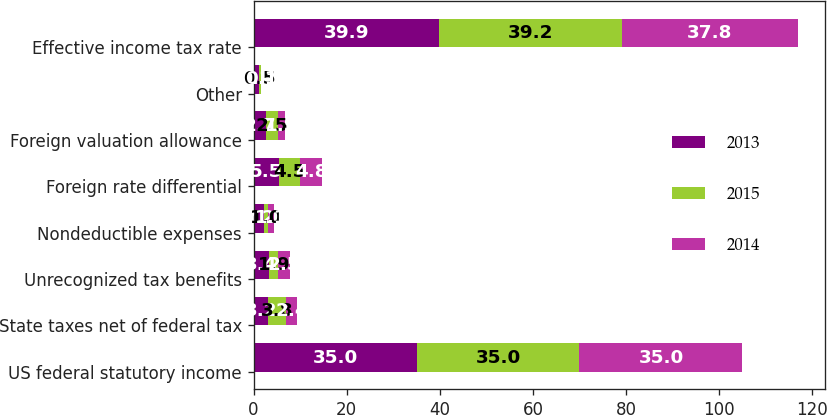Convert chart. <chart><loc_0><loc_0><loc_500><loc_500><stacked_bar_chart><ecel><fcel>US federal statutory income<fcel>State taxes net of federal tax<fcel>Unrecognized tax benefits<fcel>Nondeductible expenses<fcel>Foreign rate differential<fcel>Foreign valuation allowance<fcel>Other<fcel>Effective income tax rate<nl><fcel>2013<fcel>35<fcel>3.2<fcel>3.4<fcel>2.2<fcel>5.5<fcel>2.7<fcel>1.1<fcel>39.9<nl><fcel>2015<fcel>35<fcel>3.8<fcel>1.9<fcel>1<fcel>4.5<fcel>2.5<fcel>0.5<fcel>39.2<nl><fcel>2014<fcel>35<fcel>2.4<fcel>2.5<fcel>1.1<fcel>4.8<fcel>1.5<fcel>0.1<fcel>37.8<nl></chart> 